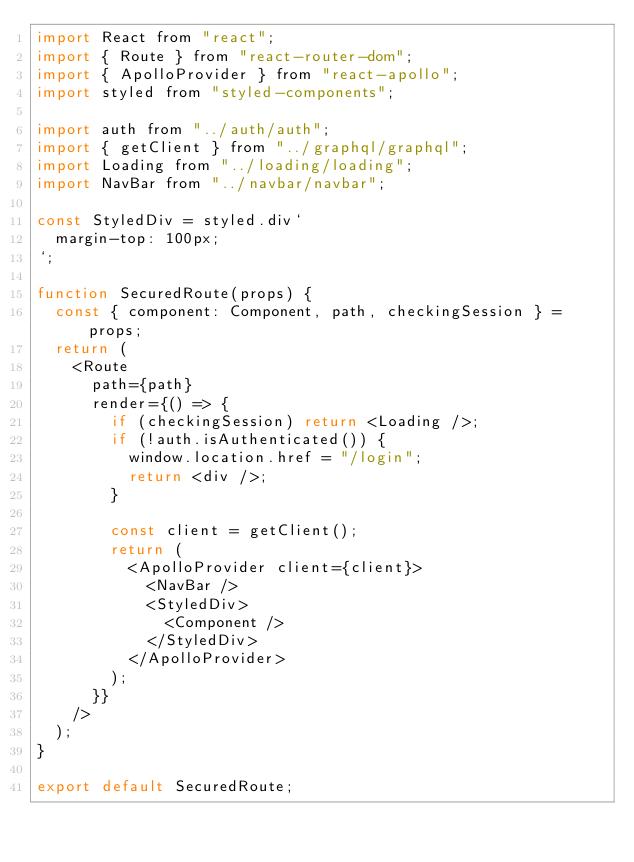<code> <loc_0><loc_0><loc_500><loc_500><_JavaScript_>import React from "react";
import { Route } from "react-router-dom";
import { ApolloProvider } from "react-apollo";
import styled from "styled-components";

import auth from "../auth/auth";
import { getClient } from "../graphql/graphql";
import Loading from "../loading/loading";
import NavBar from "../navbar/navbar";

const StyledDiv = styled.div`
  margin-top: 100px;
`;

function SecuredRoute(props) {
  const { component: Component, path, checkingSession } = props;
  return (
    <Route
      path={path}
      render={() => {
        if (checkingSession) return <Loading />;
        if (!auth.isAuthenticated()) {
          window.location.href = "/login";
          return <div />;
        }

        const client = getClient();
        return (
          <ApolloProvider client={client}>
            <NavBar />
            <StyledDiv>
              <Component />
            </StyledDiv>
          </ApolloProvider>
        );
      }}
    />
  );
}

export default SecuredRoute;
</code> 